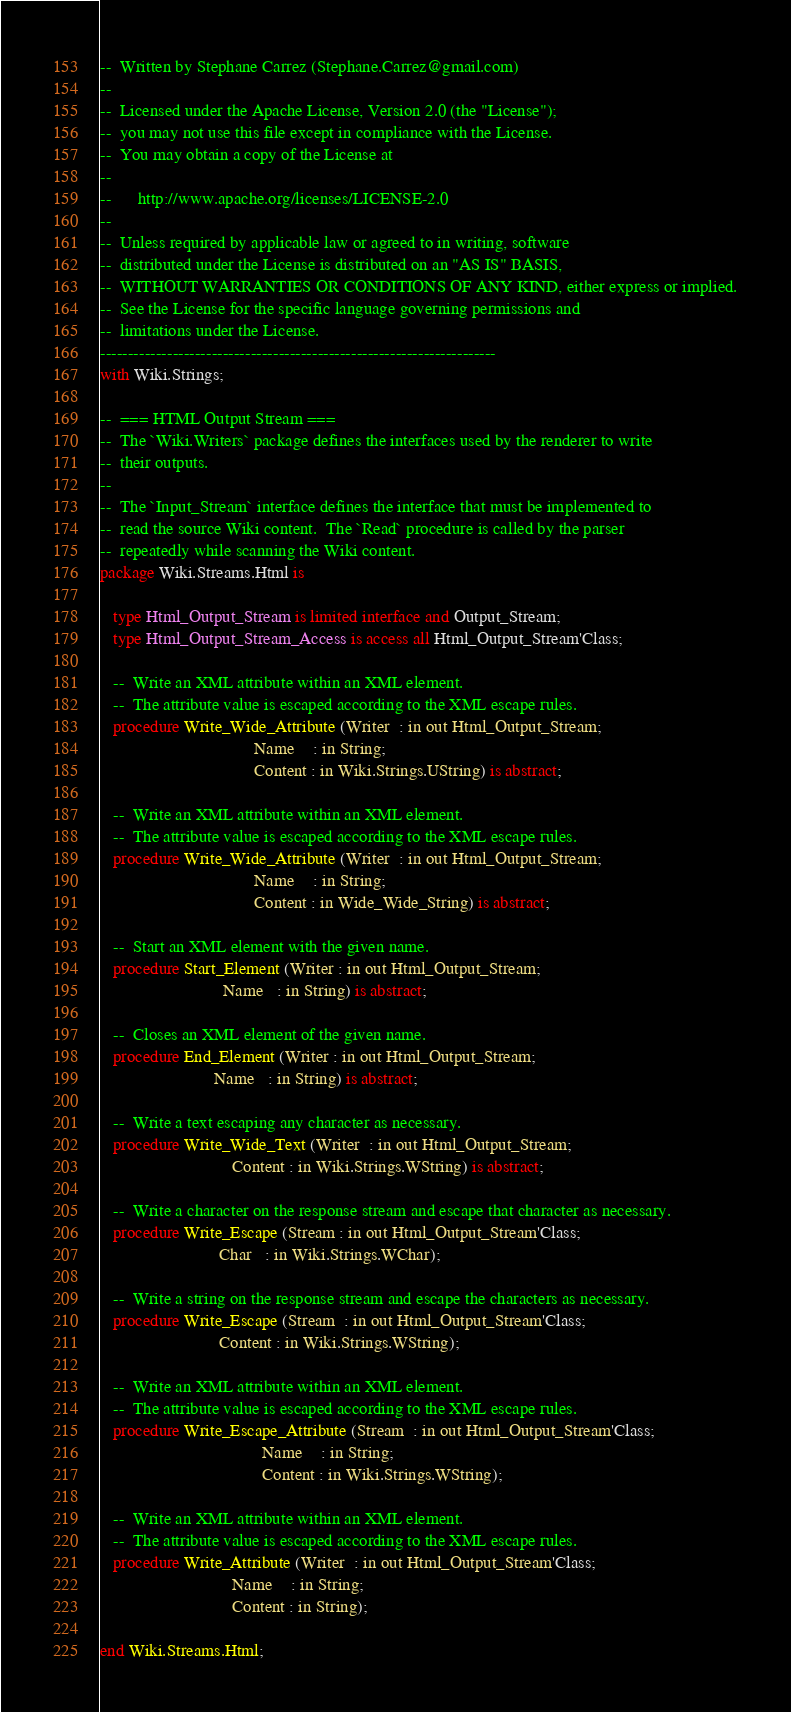Convert code to text. <code><loc_0><loc_0><loc_500><loc_500><_Ada_>--  Written by Stephane Carrez (Stephane.Carrez@gmail.com)
--
--  Licensed under the Apache License, Version 2.0 (the "License");
--  you may not use this file except in compliance with the License.
--  You may obtain a copy of the License at
--
--      http://www.apache.org/licenses/LICENSE-2.0
--
--  Unless required by applicable law or agreed to in writing, software
--  distributed under the License is distributed on an "AS IS" BASIS,
--  WITHOUT WARRANTIES OR CONDITIONS OF ANY KIND, either express or implied.
--  See the License for the specific language governing permissions and
--  limitations under the License.
-----------------------------------------------------------------------
with Wiki.Strings;

--  === HTML Output Stream ===
--  The `Wiki.Writers` package defines the interfaces used by the renderer to write
--  their outputs.
--
--  The `Input_Stream` interface defines the interface that must be implemented to
--  read the source Wiki content.  The `Read` procedure is called by the parser
--  repeatedly while scanning the Wiki content.
package Wiki.Streams.Html is

   type Html_Output_Stream is limited interface and Output_Stream;
   type Html_Output_Stream_Access is access all Html_Output_Stream'Class;

   --  Write an XML attribute within an XML element.
   --  The attribute value is escaped according to the XML escape rules.
   procedure Write_Wide_Attribute (Writer  : in out Html_Output_Stream;
                                   Name    : in String;
                                   Content : in Wiki.Strings.UString) is abstract;

   --  Write an XML attribute within an XML element.
   --  The attribute value is escaped according to the XML escape rules.
   procedure Write_Wide_Attribute (Writer  : in out Html_Output_Stream;
                                   Name    : in String;
                                   Content : in Wide_Wide_String) is abstract;

   --  Start an XML element with the given name.
   procedure Start_Element (Writer : in out Html_Output_Stream;
                            Name   : in String) is abstract;

   --  Closes an XML element of the given name.
   procedure End_Element (Writer : in out Html_Output_Stream;
                          Name   : in String) is abstract;

   --  Write a text escaping any character as necessary.
   procedure Write_Wide_Text (Writer  : in out Html_Output_Stream;
                              Content : in Wiki.Strings.WString) is abstract;

   --  Write a character on the response stream and escape that character as necessary.
   procedure Write_Escape (Stream : in out Html_Output_Stream'Class;
                           Char   : in Wiki.Strings.WChar);

   --  Write a string on the response stream and escape the characters as necessary.
   procedure Write_Escape (Stream  : in out Html_Output_Stream'Class;
                           Content : in Wiki.Strings.WString);

   --  Write an XML attribute within an XML element.
   --  The attribute value is escaped according to the XML escape rules.
   procedure Write_Escape_Attribute (Stream  : in out Html_Output_Stream'Class;
                                     Name    : in String;
                                     Content : in Wiki.Strings.WString);

   --  Write an XML attribute within an XML element.
   --  The attribute value is escaped according to the XML escape rules.
   procedure Write_Attribute (Writer  : in out Html_Output_Stream'Class;
                              Name    : in String;
                              Content : in String);

end Wiki.Streams.Html;
</code> 